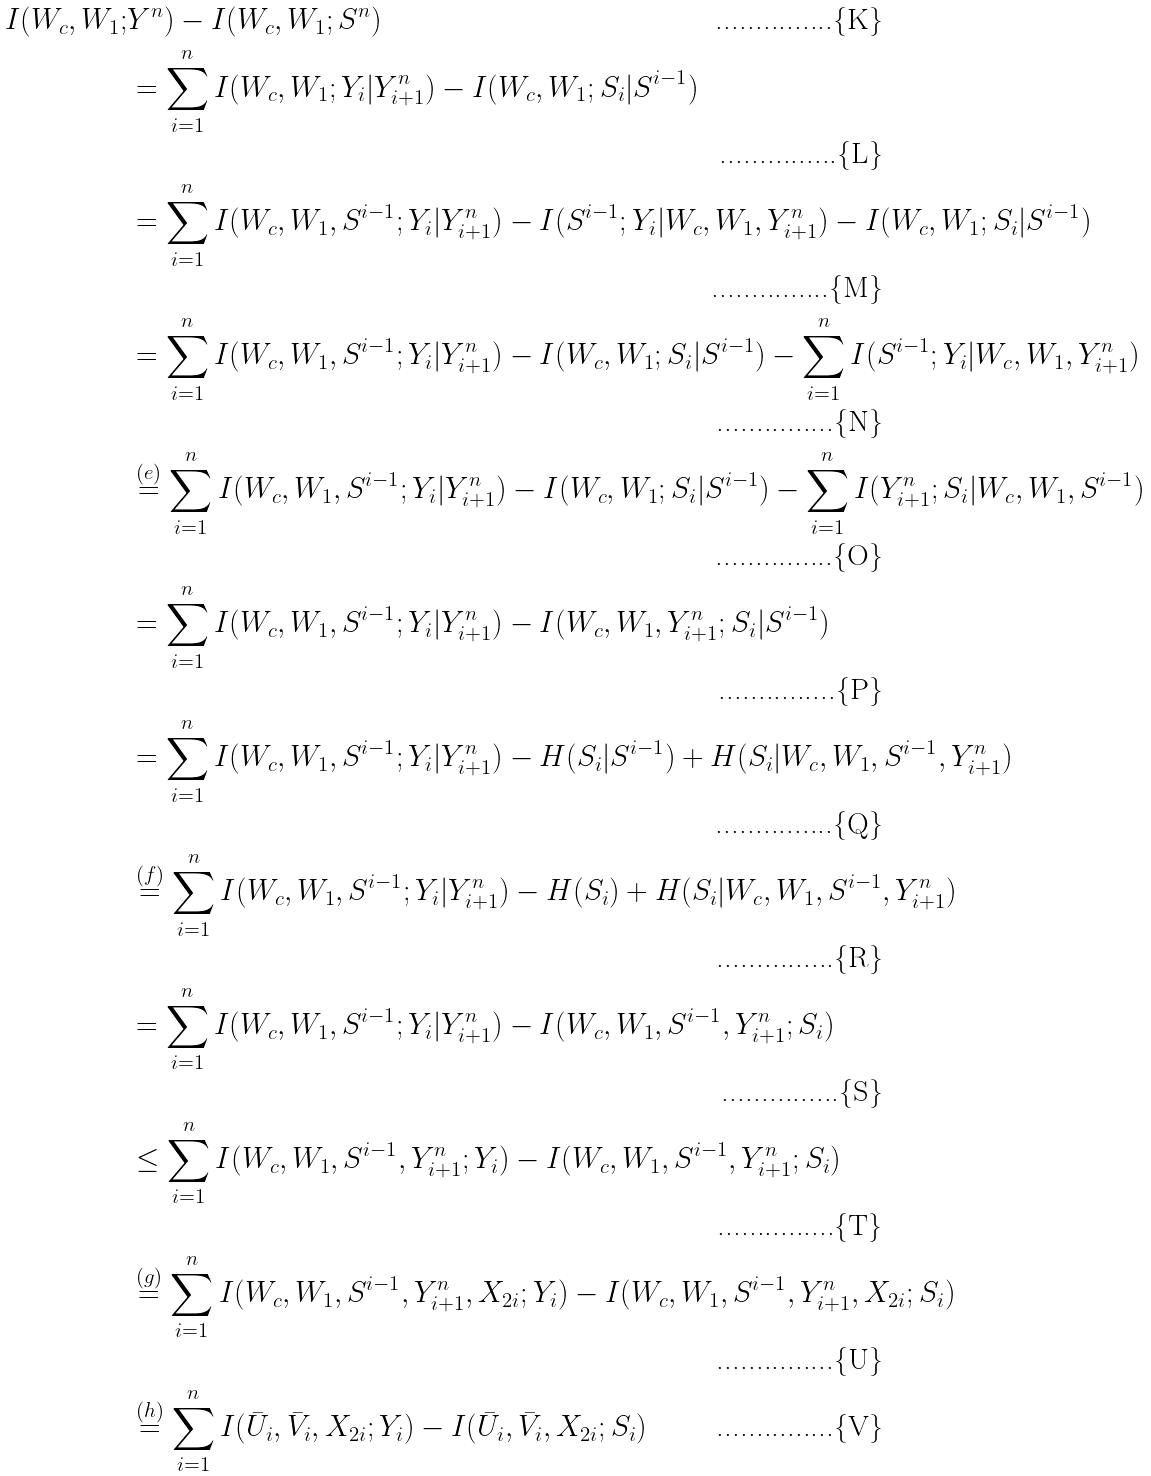Convert formula to latex. <formula><loc_0><loc_0><loc_500><loc_500>I ( W _ { c } , W _ { 1 } ; & Y ^ { n } ) - I ( W _ { c } , W _ { 1 } ; S ^ { n } ) \\ & = \sum _ { i = 1 } ^ { n } I ( W _ { c } , W _ { 1 } ; Y _ { i } | Y ^ { n } _ { i + 1 } ) - I ( W _ { c } , W _ { 1 } ; S _ { i } | S ^ { i - 1 } ) \\ & = \sum _ { i = 1 } ^ { n } I ( W _ { c } , W _ { 1 } , S ^ { i - 1 } ; Y _ { i } | Y ^ { n } _ { i + 1 } ) - I ( S ^ { i - 1 } ; Y _ { i } | W _ { c } , W _ { 1 } , Y ^ { n } _ { i + 1 } ) - I ( W _ { c } , W _ { 1 } ; S _ { i } | S ^ { i - 1 } ) \\ & = \sum _ { i = 1 } ^ { n } I ( W _ { c } , W _ { 1 } , S ^ { i - 1 } ; Y _ { i } | Y ^ { n } _ { i + 1 } ) - I ( W _ { c } , W _ { 1 } ; S _ { i } | S ^ { i - 1 } ) - \sum _ { i = 1 } ^ { n } I ( S ^ { i - 1 } ; Y _ { i } | W _ { c } , W _ { 1 } , Y ^ { n } _ { i + 1 } ) \\ & \stackrel { ( e ) } { = } \sum _ { i = 1 } ^ { n } I ( W _ { c } , W _ { 1 } , S ^ { i - 1 } ; Y _ { i } | Y ^ { n } _ { i + 1 } ) - I ( W _ { c } , W _ { 1 } ; S _ { i } | S ^ { i - 1 } ) - \sum _ { i = 1 } ^ { n } I ( Y ^ { n } _ { i + 1 } ; S _ { i } | W _ { c } , W _ { 1 } , S ^ { i - 1 } ) \\ & = \sum _ { i = 1 } ^ { n } I ( W _ { c } , W _ { 1 } , S ^ { i - 1 } ; Y _ { i } | Y ^ { n } _ { i + 1 } ) - I ( W _ { c } , W _ { 1 } , Y ^ { n } _ { i + 1 } ; S _ { i } | S ^ { i - 1 } ) \\ & = \sum _ { i = 1 } ^ { n } I ( W _ { c } , W _ { 1 } , S ^ { i - 1 } ; Y _ { i } | Y ^ { n } _ { i + 1 } ) - H ( S _ { i } | S ^ { i - 1 } ) + H ( S _ { i } | W _ { c } , W _ { 1 } , S ^ { i - 1 } , Y ^ { n } _ { i + 1 } ) \\ & \stackrel { ( f ) } { = } \sum _ { i = 1 } ^ { n } I ( W _ { c } , W _ { 1 } , S ^ { i - 1 } ; Y _ { i } | Y ^ { n } _ { i + 1 } ) - H ( S _ { i } ) + H ( S _ { i } | W _ { c } , W _ { 1 } , S ^ { i - 1 } , Y ^ { n } _ { i + 1 } ) \\ & = \sum _ { i = 1 } ^ { n } I ( W _ { c } , W _ { 1 } , S ^ { i - 1 } ; Y _ { i } | Y ^ { n } _ { i + 1 } ) - I ( W _ { c } , W _ { 1 } , S ^ { i - 1 } , Y ^ { n } _ { i + 1 } ; S _ { i } ) \\ & \leq \sum _ { i = 1 } ^ { n } I ( W _ { c } , W _ { 1 } , S ^ { i - 1 } , Y ^ { n } _ { i + 1 } ; Y _ { i } ) - I ( W _ { c } , W _ { 1 } , S ^ { i - 1 } , Y ^ { n } _ { i + 1 } ; S _ { i } ) \\ & \stackrel { ( g ) } { = } \sum _ { i = 1 } ^ { n } I ( W _ { c } , W _ { 1 } , S ^ { i - 1 } , Y ^ { n } _ { i + 1 } , X _ { 2 i } ; Y _ { i } ) - I ( W _ { c } , W _ { 1 } , S ^ { i - 1 } , Y ^ { n } _ { i + 1 } , X _ { 2 i } ; S _ { i } ) \\ & \stackrel { ( h ) } { = } \sum _ { i = 1 } ^ { n } I ( \bar { U } _ { i } , \bar { V } _ { i } , X _ { 2 i } ; Y _ { i } ) - I ( \bar { U } _ { i } , \bar { V } _ { i } , X _ { 2 i } ; S _ { i } )</formula> 